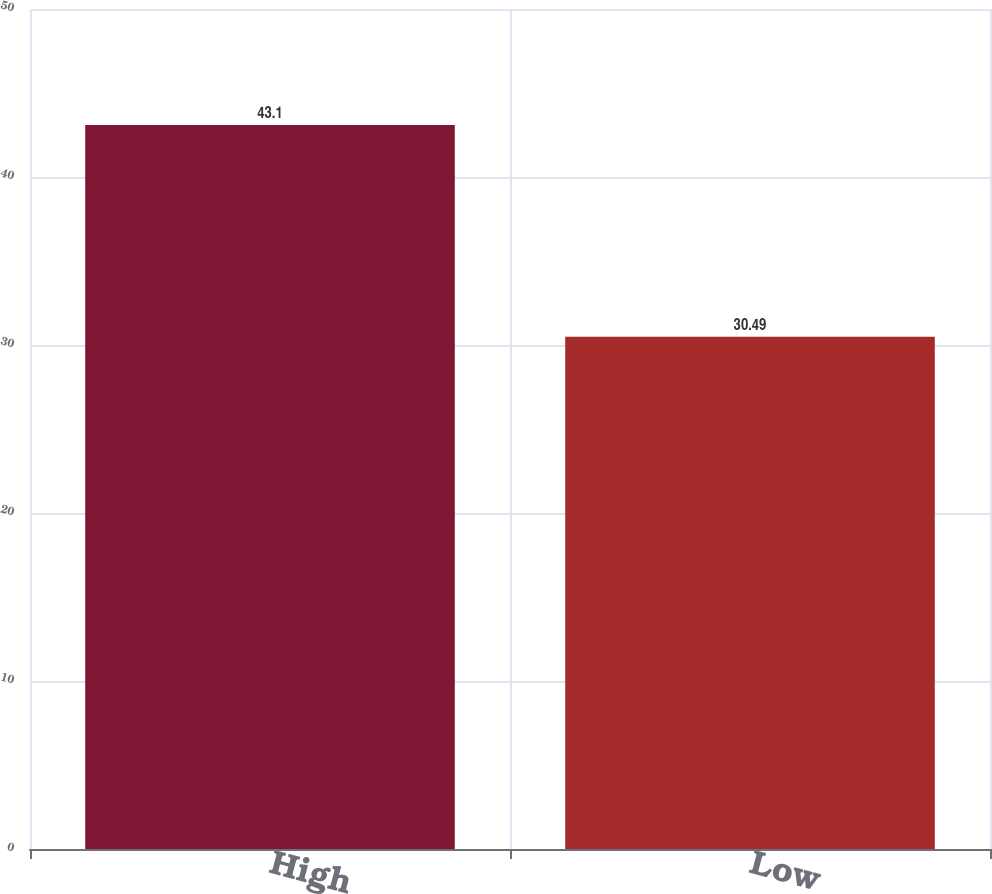<chart> <loc_0><loc_0><loc_500><loc_500><bar_chart><fcel>High<fcel>Low<nl><fcel>43.1<fcel>30.49<nl></chart> 